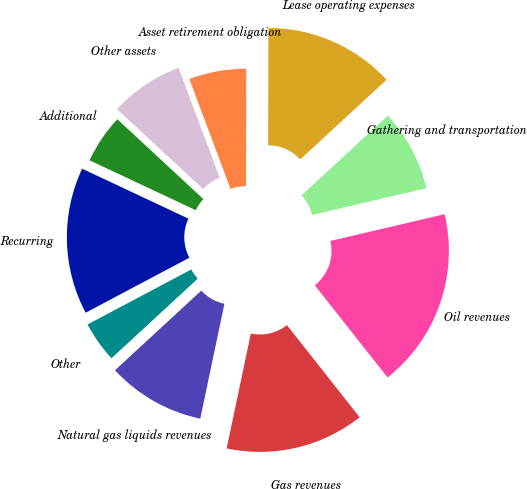Convert chart. <chart><loc_0><loc_0><loc_500><loc_500><pie_chart><fcel>Oil revenues<fcel>Gas revenues<fcel>Natural gas liquids revenues<fcel>Other<fcel>Recurring<fcel>Additional<fcel>Other assets<fcel>Asset retirement obligation<fcel>Lease operating expenses<fcel>Gathering and transportation<nl><fcel>18.03%<fcel>13.93%<fcel>9.84%<fcel>4.1%<fcel>14.75%<fcel>4.92%<fcel>7.38%<fcel>5.74%<fcel>13.11%<fcel>8.2%<nl></chart> 